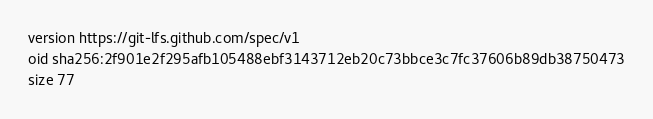Convert code to text. <code><loc_0><loc_0><loc_500><loc_500><_YAML_>version https://git-lfs.github.com/spec/v1
oid sha256:2f901e2f295afb105488ebf3143712eb20c73bbce3c7fc37606b89db38750473
size 77
</code> 